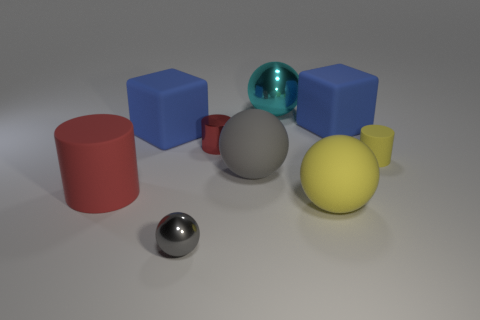Subtract all yellow spheres. How many spheres are left? 3 Subtract all tiny cylinders. How many cylinders are left? 1 Subtract all green balls. Subtract all red cubes. How many balls are left? 4 Add 1 big yellow balls. How many objects exist? 10 Subtract all cylinders. How many objects are left? 6 Subtract all tiny gray blocks. Subtract all cylinders. How many objects are left? 6 Add 2 yellow matte things. How many yellow matte things are left? 4 Add 6 tiny red rubber things. How many tiny red rubber things exist? 6 Subtract 2 blue blocks. How many objects are left? 7 